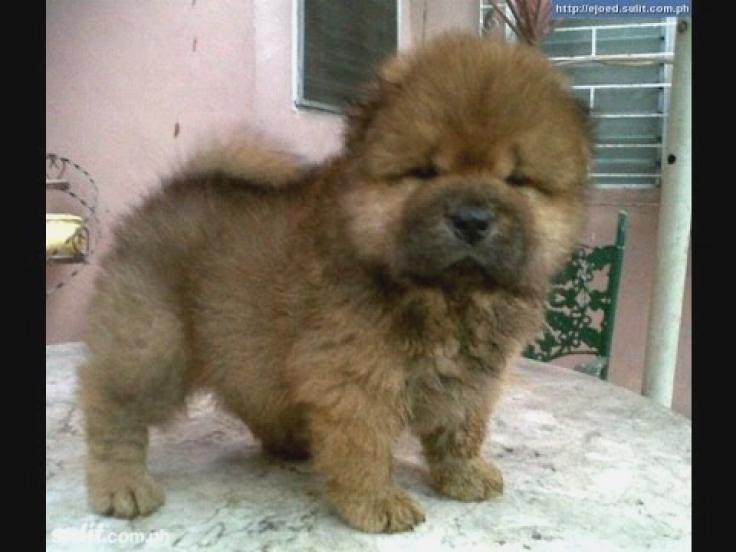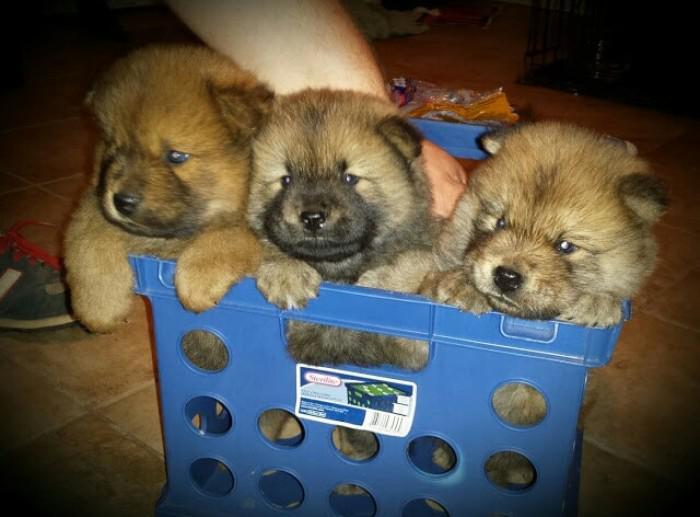The first image is the image on the left, the second image is the image on the right. Analyze the images presented: Is the assertion "There are puppies in each image." valid? Answer yes or no. Yes. The first image is the image on the left, the second image is the image on the right. Considering the images on both sides, is "There are four dogs in total." valid? Answer yes or no. Yes. 